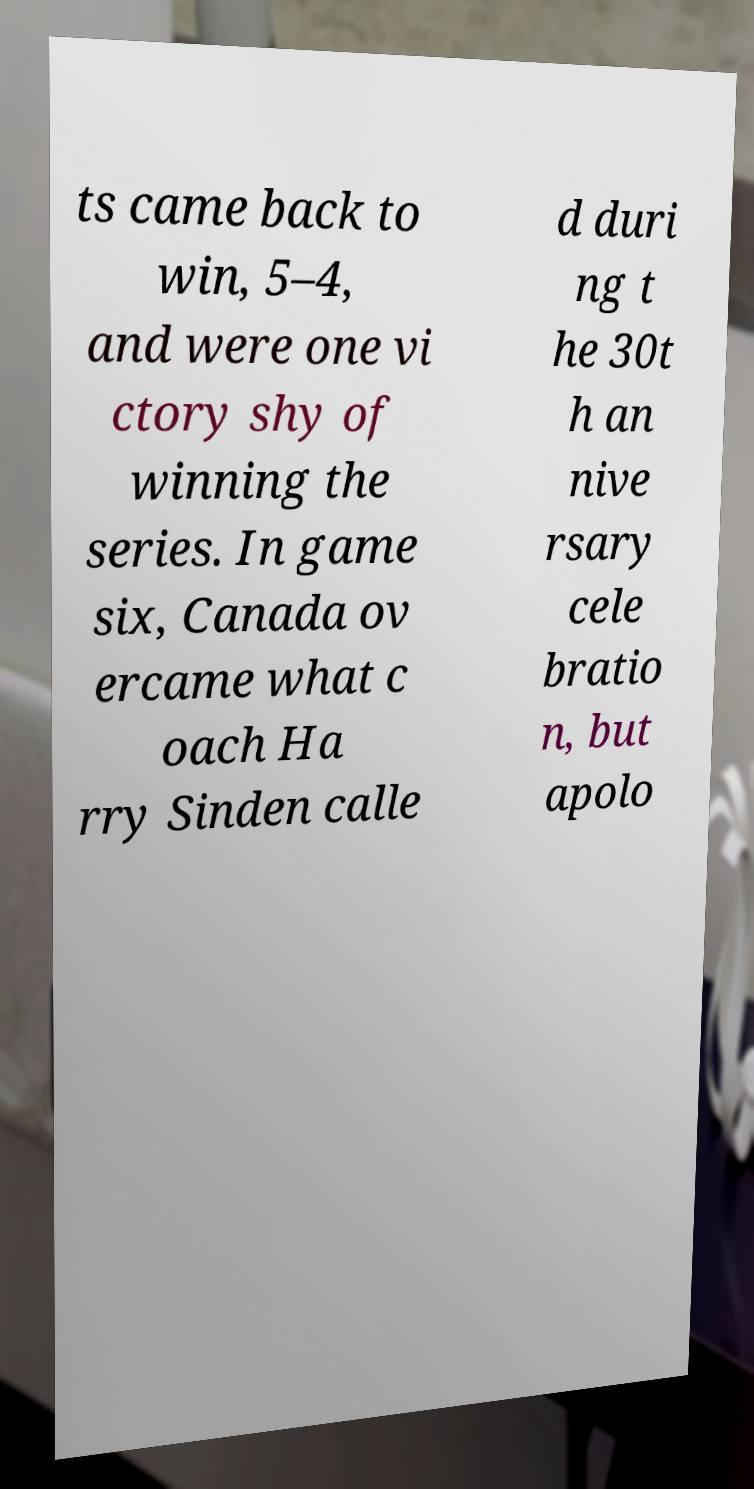I need the written content from this picture converted into text. Can you do that? ts came back to win, 5–4, and were one vi ctory shy of winning the series. In game six, Canada ov ercame what c oach Ha rry Sinden calle d duri ng t he 30t h an nive rsary cele bratio n, but apolo 